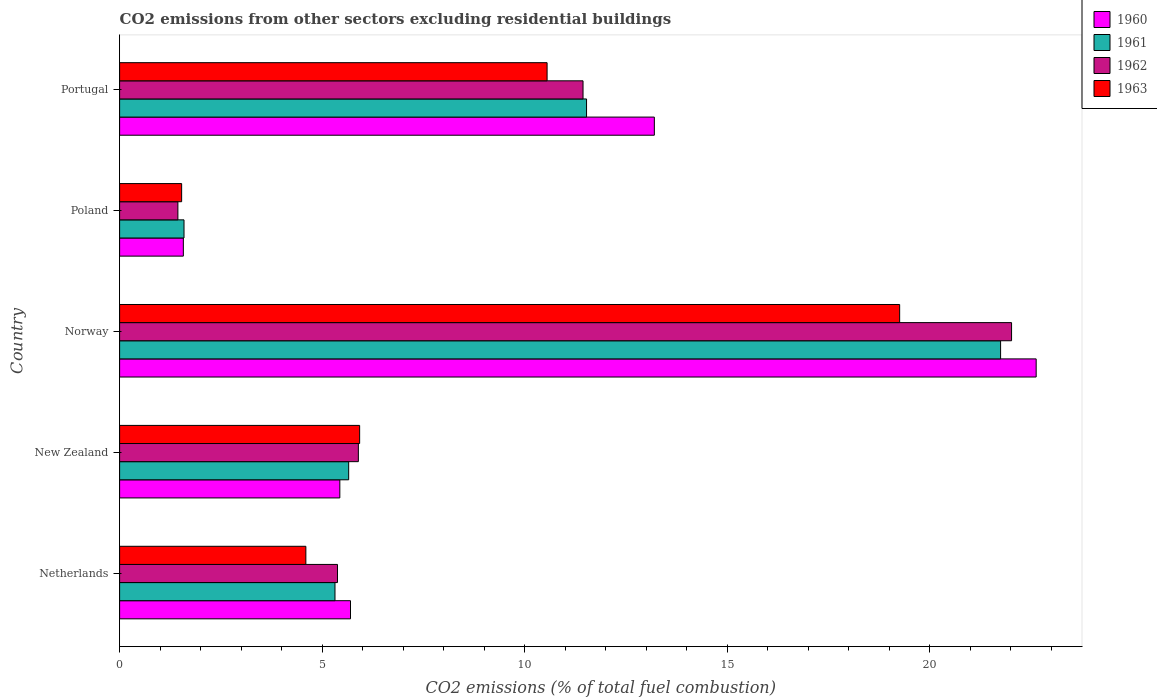How many different coloured bars are there?
Make the answer very short. 4. What is the label of the 4th group of bars from the top?
Your answer should be very brief. New Zealand. What is the total CO2 emitted in 1963 in Norway?
Ensure brevity in your answer.  19.26. Across all countries, what is the maximum total CO2 emitted in 1960?
Your answer should be very brief. 22.63. Across all countries, what is the minimum total CO2 emitted in 1961?
Keep it short and to the point. 1.59. In which country was the total CO2 emitted in 1963 minimum?
Keep it short and to the point. Poland. What is the total total CO2 emitted in 1963 in the graph?
Ensure brevity in your answer.  41.87. What is the difference between the total CO2 emitted in 1962 in Netherlands and that in Portugal?
Offer a very short reply. -6.06. What is the difference between the total CO2 emitted in 1962 in Poland and the total CO2 emitted in 1961 in Portugal?
Give a very brief answer. -10.09. What is the average total CO2 emitted in 1963 per country?
Your answer should be very brief. 8.37. What is the difference between the total CO2 emitted in 1962 and total CO2 emitted in 1963 in New Zealand?
Make the answer very short. -0.03. What is the ratio of the total CO2 emitted in 1963 in Netherlands to that in Poland?
Provide a short and direct response. 3. Is the total CO2 emitted in 1961 in Norway less than that in Poland?
Offer a terse response. No. What is the difference between the highest and the second highest total CO2 emitted in 1961?
Provide a succinct answer. 10.22. What is the difference between the highest and the lowest total CO2 emitted in 1960?
Provide a succinct answer. 21.05. In how many countries, is the total CO2 emitted in 1962 greater than the average total CO2 emitted in 1962 taken over all countries?
Offer a terse response. 2. Is the sum of the total CO2 emitted in 1963 in New Zealand and Poland greater than the maximum total CO2 emitted in 1962 across all countries?
Keep it short and to the point. No. Are all the bars in the graph horizontal?
Your response must be concise. Yes. What is the title of the graph?
Give a very brief answer. CO2 emissions from other sectors excluding residential buildings. Does "1992" appear as one of the legend labels in the graph?
Ensure brevity in your answer.  No. What is the label or title of the X-axis?
Keep it short and to the point. CO2 emissions (% of total fuel combustion). What is the CO2 emissions (% of total fuel combustion) of 1960 in Netherlands?
Your answer should be very brief. 5.7. What is the CO2 emissions (% of total fuel combustion) of 1961 in Netherlands?
Make the answer very short. 5.32. What is the CO2 emissions (% of total fuel combustion) in 1962 in Netherlands?
Ensure brevity in your answer.  5.38. What is the CO2 emissions (% of total fuel combustion) in 1963 in Netherlands?
Ensure brevity in your answer.  4.6. What is the CO2 emissions (% of total fuel combustion) in 1960 in New Zealand?
Provide a short and direct response. 5.44. What is the CO2 emissions (% of total fuel combustion) in 1961 in New Zealand?
Your answer should be compact. 5.66. What is the CO2 emissions (% of total fuel combustion) of 1962 in New Zealand?
Provide a short and direct response. 5.89. What is the CO2 emissions (% of total fuel combustion) in 1963 in New Zealand?
Provide a succinct answer. 5.93. What is the CO2 emissions (% of total fuel combustion) in 1960 in Norway?
Offer a very short reply. 22.63. What is the CO2 emissions (% of total fuel combustion) in 1961 in Norway?
Your response must be concise. 21.75. What is the CO2 emissions (% of total fuel combustion) in 1962 in Norway?
Offer a terse response. 22.02. What is the CO2 emissions (% of total fuel combustion) of 1963 in Norway?
Offer a very short reply. 19.26. What is the CO2 emissions (% of total fuel combustion) of 1960 in Poland?
Provide a short and direct response. 1.57. What is the CO2 emissions (% of total fuel combustion) of 1961 in Poland?
Keep it short and to the point. 1.59. What is the CO2 emissions (% of total fuel combustion) of 1962 in Poland?
Provide a short and direct response. 1.44. What is the CO2 emissions (% of total fuel combustion) in 1963 in Poland?
Give a very brief answer. 1.53. What is the CO2 emissions (% of total fuel combustion) in 1960 in Portugal?
Provide a succinct answer. 13.2. What is the CO2 emissions (% of total fuel combustion) in 1961 in Portugal?
Give a very brief answer. 11.53. What is the CO2 emissions (% of total fuel combustion) in 1962 in Portugal?
Make the answer very short. 11.44. What is the CO2 emissions (% of total fuel combustion) of 1963 in Portugal?
Provide a short and direct response. 10.55. Across all countries, what is the maximum CO2 emissions (% of total fuel combustion) in 1960?
Your response must be concise. 22.63. Across all countries, what is the maximum CO2 emissions (% of total fuel combustion) of 1961?
Your answer should be compact. 21.75. Across all countries, what is the maximum CO2 emissions (% of total fuel combustion) in 1962?
Ensure brevity in your answer.  22.02. Across all countries, what is the maximum CO2 emissions (% of total fuel combustion) in 1963?
Provide a short and direct response. 19.26. Across all countries, what is the minimum CO2 emissions (% of total fuel combustion) of 1960?
Your answer should be very brief. 1.57. Across all countries, what is the minimum CO2 emissions (% of total fuel combustion) of 1961?
Ensure brevity in your answer.  1.59. Across all countries, what is the minimum CO2 emissions (% of total fuel combustion) of 1962?
Ensure brevity in your answer.  1.44. Across all countries, what is the minimum CO2 emissions (% of total fuel combustion) in 1963?
Your response must be concise. 1.53. What is the total CO2 emissions (% of total fuel combustion) of 1960 in the graph?
Ensure brevity in your answer.  48.54. What is the total CO2 emissions (% of total fuel combustion) of 1961 in the graph?
Your answer should be very brief. 45.84. What is the total CO2 emissions (% of total fuel combustion) in 1962 in the graph?
Make the answer very short. 46.17. What is the total CO2 emissions (% of total fuel combustion) in 1963 in the graph?
Make the answer very short. 41.87. What is the difference between the CO2 emissions (% of total fuel combustion) of 1960 in Netherlands and that in New Zealand?
Your answer should be very brief. 0.26. What is the difference between the CO2 emissions (% of total fuel combustion) of 1961 in Netherlands and that in New Zealand?
Offer a very short reply. -0.34. What is the difference between the CO2 emissions (% of total fuel combustion) in 1962 in Netherlands and that in New Zealand?
Keep it short and to the point. -0.52. What is the difference between the CO2 emissions (% of total fuel combustion) of 1963 in Netherlands and that in New Zealand?
Provide a short and direct response. -1.33. What is the difference between the CO2 emissions (% of total fuel combustion) in 1960 in Netherlands and that in Norway?
Give a very brief answer. -16.93. What is the difference between the CO2 emissions (% of total fuel combustion) of 1961 in Netherlands and that in Norway?
Ensure brevity in your answer.  -16.43. What is the difference between the CO2 emissions (% of total fuel combustion) of 1962 in Netherlands and that in Norway?
Ensure brevity in your answer.  -16.64. What is the difference between the CO2 emissions (% of total fuel combustion) of 1963 in Netherlands and that in Norway?
Keep it short and to the point. -14.66. What is the difference between the CO2 emissions (% of total fuel combustion) in 1960 in Netherlands and that in Poland?
Offer a very short reply. 4.13. What is the difference between the CO2 emissions (% of total fuel combustion) of 1961 in Netherlands and that in Poland?
Your answer should be very brief. 3.73. What is the difference between the CO2 emissions (% of total fuel combustion) in 1962 in Netherlands and that in Poland?
Your response must be concise. 3.94. What is the difference between the CO2 emissions (% of total fuel combustion) of 1963 in Netherlands and that in Poland?
Keep it short and to the point. 3.07. What is the difference between the CO2 emissions (% of total fuel combustion) of 1960 in Netherlands and that in Portugal?
Your answer should be very brief. -7.5. What is the difference between the CO2 emissions (% of total fuel combustion) in 1961 in Netherlands and that in Portugal?
Ensure brevity in your answer.  -6.21. What is the difference between the CO2 emissions (% of total fuel combustion) in 1962 in Netherlands and that in Portugal?
Your answer should be very brief. -6.06. What is the difference between the CO2 emissions (% of total fuel combustion) of 1963 in Netherlands and that in Portugal?
Provide a short and direct response. -5.96. What is the difference between the CO2 emissions (% of total fuel combustion) in 1960 in New Zealand and that in Norway?
Provide a short and direct response. -17.19. What is the difference between the CO2 emissions (% of total fuel combustion) of 1961 in New Zealand and that in Norway?
Provide a succinct answer. -16.09. What is the difference between the CO2 emissions (% of total fuel combustion) in 1962 in New Zealand and that in Norway?
Make the answer very short. -16.13. What is the difference between the CO2 emissions (% of total fuel combustion) of 1963 in New Zealand and that in Norway?
Provide a succinct answer. -13.33. What is the difference between the CO2 emissions (% of total fuel combustion) in 1960 in New Zealand and that in Poland?
Give a very brief answer. 3.86. What is the difference between the CO2 emissions (% of total fuel combustion) in 1961 in New Zealand and that in Poland?
Your answer should be very brief. 4.07. What is the difference between the CO2 emissions (% of total fuel combustion) of 1962 in New Zealand and that in Poland?
Your answer should be very brief. 4.45. What is the difference between the CO2 emissions (% of total fuel combustion) of 1963 in New Zealand and that in Poland?
Ensure brevity in your answer.  4.39. What is the difference between the CO2 emissions (% of total fuel combustion) of 1960 in New Zealand and that in Portugal?
Provide a short and direct response. -7.76. What is the difference between the CO2 emissions (% of total fuel combustion) in 1961 in New Zealand and that in Portugal?
Provide a succinct answer. -5.87. What is the difference between the CO2 emissions (% of total fuel combustion) of 1962 in New Zealand and that in Portugal?
Make the answer very short. -5.55. What is the difference between the CO2 emissions (% of total fuel combustion) of 1963 in New Zealand and that in Portugal?
Give a very brief answer. -4.63. What is the difference between the CO2 emissions (% of total fuel combustion) in 1960 in Norway and that in Poland?
Your answer should be very brief. 21.05. What is the difference between the CO2 emissions (% of total fuel combustion) of 1961 in Norway and that in Poland?
Give a very brief answer. 20.16. What is the difference between the CO2 emissions (% of total fuel combustion) of 1962 in Norway and that in Poland?
Keep it short and to the point. 20.58. What is the difference between the CO2 emissions (% of total fuel combustion) of 1963 in Norway and that in Poland?
Your response must be concise. 17.73. What is the difference between the CO2 emissions (% of total fuel combustion) in 1960 in Norway and that in Portugal?
Offer a very short reply. 9.43. What is the difference between the CO2 emissions (% of total fuel combustion) in 1961 in Norway and that in Portugal?
Ensure brevity in your answer.  10.22. What is the difference between the CO2 emissions (% of total fuel combustion) in 1962 in Norway and that in Portugal?
Ensure brevity in your answer.  10.58. What is the difference between the CO2 emissions (% of total fuel combustion) in 1963 in Norway and that in Portugal?
Ensure brevity in your answer.  8.7. What is the difference between the CO2 emissions (% of total fuel combustion) of 1960 in Poland and that in Portugal?
Keep it short and to the point. -11.63. What is the difference between the CO2 emissions (% of total fuel combustion) in 1961 in Poland and that in Portugal?
Ensure brevity in your answer.  -9.94. What is the difference between the CO2 emissions (% of total fuel combustion) in 1962 in Poland and that in Portugal?
Ensure brevity in your answer.  -10. What is the difference between the CO2 emissions (% of total fuel combustion) in 1963 in Poland and that in Portugal?
Keep it short and to the point. -9.02. What is the difference between the CO2 emissions (% of total fuel combustion) in 1960 in Netherlands and the CO2 emissions (% of total fuel combustion) in 1961 in New Zealand?
Ensure brevity in your answer.  0.05. What is the difference between the CO2 emissions (% of total fuel combustion) in 1960 in Netherlands and the CO2 emissions (% of total fuel combustion) in 1962 in New Zealand?
Ensure brevity in your answer.  -0.19. What is the difference between the CO2 emissions (% of total fuel combustion) in 1960 in Netherlands and the CO2 emissions (% of total fuel combustion) in 1963 in New Zealand?
Offer a very short reply. -0.23. What is the difference between the CO2 emissions (% of total fuel combustion) in 1961 in Netherlands and the CO2 emissions (% of total fuel combustion) in 1962 in New Zealand?
Give a very brief answer. -0.58. What is the difference between the CO2 emissions (% of total fuel combustion) in 1961 in Netherlands and the CO2 emissions (% of total fuel combustion) in 1963 in New Zealand?
Provide a short and direct response. -0.61. What is the difference between the CO2 emissions (% of total fuel combustion) of 1962 in Netherlands and the CO2 emissions (% of total fuel combustion) of 1963 in New Zealand?
Make the answer very short. -0.55. What is the difference between the CO2 emissions (% of total fuel combustion) of 1960 in Netherlands and the CO2 emissions (% of total fuel combustion) of 1961 in Norway?
Your response must be concise. -16.05. What is the difference between the CO2 emissions (% of total fuel combustion) in 1960 in Netherlands and the CO2 emissions (% of total fuel combustion) in 1962 in Norway?
Provide a succinct answer. -16.32. What is the difference between the CO2 emissions (% of total fuel combustion) of 1960 in Netherlands and the CO2 emissions (% of total fuel combustion) of 1963 in Norway?
Your answer should be very brief. -13.56. What is the difference between the CO2 emissions (% of total fuel combustion) of 1961 in Netherlands and the CO2 emissions (% of total fuel combustion) of 1962 in Norway?
Provide a short and direct response. -16.7. What is the difference between the CO2 emissions (% of total fuel combustion) of 1961 in Netherlands and the CO2 emissions (% of total fuel combustion) of 1963 in Norway?
Your response must be concise. -13.94. What is the difference between the CO2 emissions (% of total fuel combustion) of 1962 in Netherlands and the CO2 emissions (% of total fuel combustion) of 1963 in Norway?
Make the answer very short. -13.88. What is the difference between the CO2 emissions (% of total fuel combustion) of 1960 in Netherlands and the CO2 emissions (% of total fuel combustion) of 1961 in Poland?
Provide a short and direct response. 4.11. What is the difference between the CO2 emissions (% of total fuel combustion) of 1960 in Netherlands and the CO2 emissions (% of total fuel combustion) of 1962 in Poland?
Your response must be concise. 4.26. What is the difference between the CO2 emissions (% of total fuel combustion) of 1960 in Netherlands and the CO2 emissions (% of total fuel combustion) of 1963 in Poland?
Your answer should be very brief. 4.17. What is the difference between the CO2 emissions (% of total fuel combustion) of 1961 in Netherlands and the CO2 emissions (% of total fuel combustion) of 1962 in Poland?
Give a very brief answer. 3.88. What is the difference between the CO2 emissions (% of total fuel combustion) of 1961 in Netherlands and the CO2 emissions (% of total fuel combustion) of 1963 in Poland?
Your response must be concise. 3.79. What is the difference between the CO2 emissions (% of total fuel combustion) in 1962 in Netherlands and the CO2 emissions (% of total fuel combustion) in 1963 in Poland?
Offer a terse response. 3.85. What is the difference between the CO2 emissions (% of total fuel combustion) in 1960 in Netherlands and the CO2 emissions (% of total fuel combustion) in 1961 in Portugal?
Offer a very short reply. -5.83. What is the difference between the CO2 emissions (% of total fuel combustion) in 1960 in Netherlands and the CO2 emissions (% of total fuel combustion) in 1962 in Portugal?
Your answer should be compact. -5.74. What is the difference between the CO2 emissions (% of total fuel combustion) in 1960 in Netherlands and the CO2 emissions (% of total fuel combustion) in 1963 in Portugal?
Your answer should be compact. -4.85. What is the difference between the CO2 emissions (% of total fuel combustion) of 1961 in Netherlands and the CO2 emissions (% of total fuel combustion) of 1962 in Portugal?
Offer a very short reply. -6.12. What is the difference between the CO2 emissions (% of total fuel combustion) in 1961 in Netherlands and the CO2 emissions (% of total fuel combustion) in 1963 in Portugal?
Provide a succinct answer. -5.24. What is the difference between the CO2 emissions (% of total fuel combustion) of 1962 in Netherlands and the CO2 emissions (% of total fuel combustion) of 1963 in Portugal?
Ensure brevity in your answer.  -5.17. What is the difference between the CO2 emissions (% of total fuel combustion) of 1960 in New Zealand and the CO2 emissions (% of total fuel combustion) of 1961 in Norway?
Your answer should be very brief. -16.31. What is the difference between the CO2 emissions (% of total fuel combustion) of 1960 in New Zealand and the CO2 emissions (% of total fuel combustion) of 1962 in Norway?
Ensure brevity in your answer.  -16.58. What is the difference between the CO2 emissions (% of total fuel combustion) of 1960 in New Zealand and the CO2 emissions (% of total fuel combustion) of 1963 in Norway?
Your answer should be compact. -13.82. What is the difference between the CO2 emissions (% of total fuel combustion) of 1961 in New Zealand and the CO2 emissions (% of total fuel combustion) of 1962 in Norway?
Make the answer very short. -16.36. What is the difference between the CO2 emissions (% of total fuel combustion) of 1961 in New Zealand and the CO2 emissions (% of total fuel combustion) of 1963 in Norway?
Give a very brief answer. -13.6. What is the difference between the CO2 emissions (% of total fuel combustion) of 1962 in New Zealand and the CO2 emissions (% of total fuel combustion) of 1963 in Norway?
Make the answer very short. -13.36. What is the difference between the CO2 emissions (% of total fuel combustion) of 1960 in New Zealand and the CO2 emissions (% of total fuel combustion) of 1961 in Poland?
Your answer should be compact. 3.85. What is the difference between the CO2 emissions (% of total fuel combustion) of 1960 in New Zealand and the CO2 emissions (% of total fuel combustion) of 1962 in Poland?
Offer a terse response. 4. What is the difference between the CO2 emissions (% of total fuel combustion) in 1960 in New Zealand and the CO2 emissions (% of total fuel combustion) in 1963 in Poland?
Give a very brief answer. 3.91. What is the difference between the CO2 emissions (% of total fuel combustion) of 1961 in New Zealand and the CO2 emissions (% of total fuel combustion) of 1962 in Poland?
Offer a terse response. 4.22. What is the difference between the CO2 emissions (% of total fuel combustion) of 1961 in New Zealand and the CO2 emissions (% of total fuel combustion) of 1963 in Poland?
Make the answer very short. 4.12. What is the difference between the CO2 emissions (% of total fuel combustion) of 1962 in New Zealand and the CO2 emissions (% of total fuel combustion) of 1963 in Poland?
Your response must be concise. 4.36. What is the difference between the CO2 emissions (% of total fuel combustion) in 1960 in New Zealand and the CO2 emissions (% of total fuel combustion) in 1961 in Portugal?
Your answer should be compact. -6.09. What is the difference between the CO2 emissions (% of total fuel combustion) in 1960 in New Zealand and the CO2 emissions (% of total fuel combustion) in 1962 in Portugal?
Provide a succinct answer. -6. What is the difference between the CO2 emissions (% of total fuel combustion) in 1960 in New Zealand and the CO2 emissions (% of total fuel combustion) in 1963 in Portugal?
Offer a terse response. -5.12. What is the difference between the CO2 emissions (% of total fuel combustion) of 1961 in New Zealand and the CO2 emissions (% of total fuel combustion) of 1962 in Portugal?
Offer a very short reply. -5.79. What is the difference between the CO2 emissions (% of total fuel combustion) of 1961 in New Zealand and the CO2 emissions (% of total fuel combustion) of 1963 in Portugal?
Ensure brevity in your answer.  -4.9. What is the difference between the CO2 emissions (% of total fuel combustion) in 1962 in New Zealand and the CO2 emissions (% of total fuel combustion) in 1963 in Portugal?
Keep it short and to the point. -4.66. What is the difference between the CO2 emissions (% of total fuel combustion) in 1960 in Norway and the CO2 emissions (% of total fuel combustion) in 1961 in Poland?
Provide a short and direct response. 21.04. What is the difference between the CO2 emissions (% of total fuel combustion) of 1960 in Norway and the CO2 emissions (% of total fuel combustion) of 1962 in Poland?
Give a very brief answer. 21.19. What is the difference between the CO2 emissions (% of total fuel combustion) in 1960 in Norway and the CO2 emissions (% of total fuel combustion) in 1963 in Poland?
Ensure brevity in your answer.  21.1. What is the difference between the CO2 emissions (% of total fuel combustion) in 1961 in Norway and the CO2 emissions (% of total fuel combustion) in 1962 in Poland?
Provide a short and direct response. 20.31. What is the difference between the CO2 emissions (% of total fuel combustion) of 1961 in Norway and the CO2 emissions (% of total fuel combustion) of 1963 in Poland?
Your answer should be very brief. 20.22. What is the difference between the CO2 emissions (% of total fuel combustion) in 1962 in Norway and the CO2 emissions (% of total fuel combustion) in 1963 in Poland?
Make the answer very short. 20.49. What is the difference between the CO2 emissions (% of total fuel combustion) in 1960 in Norway and the CO2 emissions (% of total fuel combustion) in 1961 in Portugal?
Provide a succinct answer. 11.1. What is the difference between the CO2 emissions (% of total fuel combustion) of 1960 in Norway and the CO2 emissions (% of total fuel combustion) of 1962 in Portugal?
Provide a succinct answer. 11.19. What is the difference between the CO2 emissions (% of total fuel combustion) in 1960 in Norway and the CO2 emissions (% of total fuel combustion) in 1963 in Portugal?
Keep it short and to the point. 12.07. What is the difference between the CO2 emissions (% of total fuel combustion) of 1961 in Norway and the CO2 emissions (% of total fuel combustion) of 1962 in Portugal?
Give a very brief answer. 10.31. What is the difference between the CO2 emissions (% of total fuel combustion) of 1961 in Norway and the CO2 emissions (% of total fuel combustion) of 1963 in Portugal?
Offer a very short reply. 11.2. What is the difference between the CO2 emissions (% of total fuel combustion) in 1962 in Norway and the CO2 emissions (% of total fuel combustion) in 1963 in Portugal?
Make the answer very short. 11.47. What is the difference between the CO2 emissions (% of total fuel combustion) in 1960 in Poland and the CO2 emissions (% of total fuel combustion) in 1961 in Portugal?
Provide a short and direct response. -9.95. What is the difference between the CO2 emissions (% of total fuel combustion) of 1960 in Poland and the CO2 emissions (% of total fuel combustion) of 1962 in Portugal?
Keep it short and to the point. -9.87. What is the difference between the CO2 emissions (% of total fuel combustion) in 1960 in Poland and the CO2 emissions (% of total fuel combustion) in 1963 in Portugal?
Provide a short and direct response. -8.98. What is the difference between the CO2 emissions (% of total fuel combustion) of 1961 in Poland and the CO2 emissions (% of total fuel combustion) of 1962 in Portugal?
Offer a terse response. -9.85. What is the difference between the CO2 emissions (% of total fuel combustion) of 1961 in Poland and the CO2 emissions (% of total fuel combustion) of 1963 in Portugal?
Your answer should be very brief. -8.96. What is the difference between the CO2 emissions (% of total fuel combustion) in 1962 in Poland and the CO2 emissions (% of total fuel combustion) in 1963 in Portugal?
Your answer should be compact. -9.11. What is the average CO2 emissions (% of total fuel combustion) in 1960 per country?
Provide a succinct answer. 9.71. What is the average CO2 emissions (% of total fuel combustion) of 1961 per country?
Provide a succinct answer. 9.17. What is the average CO2 emissions (% of total fuel combustion) of 1962 per country?
Provide a succinct answer. 9.23. What is the average CO2 emissions (% of total fuel combustion) of 1963 per country?
Offer a very short reply. 8.37. What is the difference between the CO2 emissions (% of total fuel combustion) of 1960 and CO2 emissions (% of total fuel combustion) of 1961 in Netherlands?
Keep it short and to the point. 0.38. What is the difference between the CO2 emissions (% of total fuel combustion) of 1960 and CO2 emissions (% of total fuel combustion) of 1962 in Netherlands?
Keep it short and to the point. 0.32. What is the difference between the CO2 emissions (% of total fuel combustion) in 1960 and CO2 emissions (% of total fuel combustion) in 1963 in Netherlands?
Your answer should be very brief. 1.1. What is the difference between the CO2 emissions (% of total fuel combustion) of 1961 and CO2 emissions (% of total fuel combustion) of 1962 in Netherlands?
Give a very brief answer. -0.06. What is the difference between the CO2 emissions (% of total fuel combustion) in 1961 and CO2 emissions (% of total fuel combustion) in 1963 in Netherlands?
Give a very brief answer. 0.72. What is the difference between the CO2 emissions (% of total fuel combustion) of 1962 and CO2 emissions (% of total fuel combustion) of 1963 in Netherlands?
Keep it short and to the point. 0.78. What is the difference between the CO2 emissions (% of total fuel combustion) of 1960 and CO2 emissions (% of total fuel combustion) of 1961 in New Zealand?
Your answer should be compact. -0.22. What is the difference between the CO2 emissions (% of total fuel combustion) in 1960 and CO2 emissions (% of total fuel combustion) in 1962 in New Zealand?
Your answer should be very brief. -0.46. What is the difference between the CO2 emissions (% of total fuel combustion) in 1960 and CO2 emissions (% of total fuel combustion) in 1963 in New Zealand?
Provide a short and direct response. -0.49. What is the difference between the CO2 emissions (% of total fuel combustion) of 1961 and CO2 emissions (% of total fuel combustion) of 1962 in New Zealand?
Offer a very short reply. -0.24. What is the difference between the CO2 emissions (% of total fuel combustion) of 1961 and CO2 emissions (% of total fuel combustion) of 1963 in New Zealand?
Your response must be concise. -0.27. What is the difference between the CO2 emissions (% of total fuel combustion) of 1962 and CO2 emissions (% of total fuel combustion) of 1963 in New Zealand?
Offer a terse response. -0.03. What is the difference between the CO2 emissions (% of total fuel combustion) in 1960 and CO2 emissions (% of total fuel combustion) in 1961 in Norway?
Offer a terse response. 0.88. What is the difference between the CO2 emissions (% of total fuel combustion) of 1960 and CO2 emissions (% of total fuel combustion) of 1962 in Norway?
Offer a very short reply. 0.61. What is the difference between the CO2 emissions (% of total fuel combustion) of 1960 and CO2 emissions (% of total fuel combustion) of 1963 in Norway?
Ensure brevity in your answer.  3.37. What is the difference between the CO2 emissions (% of total fuel combustion) of 1961 and CO2 emissions (% of total fuel combustion) of 1962 in Norway?
Make the answer very short. -0.27. What is the difference between the CO2 emissions (% of total fuel combustion) in 1961 and CO2 emissions (% of total fuel combustion) in 1963 in Norway?
Ensure brevity in your answer.  2.49. What is the difference between the CO2 emissions (% of total fuel combustion) in 1962 and CO2 emissions (% of total fuel combustion) in 1963 in Norway?
Give a very brief answer. 2.76. What is the difference between the CO2 emissions (% of total fuel combustion) of 1960 and CO2 emissions (% of total fuel combustion) of 1961 in Poland?
Give a very brief answer. -0.02. What is the difference between the CO2 emissions (% of total fuel combustion) of 1960 and CO2 emissions (% of total fuel combustion) of 1962 in Poland?
Ensure brevity in your answer.  0.13. What is the difference between the CO2 emissions (% of total fuel combustion) in 1960 and CO2 emissions (% of total fuel combustion) in 1963 in Poland?
Your answer should be compact. 0.04. What is the difference between the CO2 emissions (% of total fuel combustion) of 1961 and CO2 emissions (% of total fuel combustion) of 1962 in Poland?
Provide a succinct answer. 0.15. What is the difference between the CO2 emissions (% of total fuel combustion) of 1961 and CO2 emissions (% of total fuel combustion) of 1963 in Poland?
Your response must be concise. 0.06. What is the difference between the CO2 emissions (% of total fuel combustion) in 1962 and CO2 emissions (% of total fuel combustion) in 1963 in Poland?
Offer a terse response. -0.09. What is the difference between the CO2 emissions (% of total fuel combustion) in 1960 and CO2 emissions (% of total fuel combustion) in 1961 in Portugal?
Your response must be concise. 1.67. What is the difference between the CO2 emissions (% of total fuel combustion) in 1960 and CO2 emissions (% of total fuel combustion) in 1962 in Portugal?
Provide a succinct answer. 1.76. What is the difference between the CO2 emissions (% of total fuel combustion) of 1960 and CO2 emissions (% of total fuel combustion) of 1963 in Portugal?
Ensure brevity in your answer.  2.65. What is the difference between the CO2 emissions (% of total fuel combustion) in 1961 and CO2 emissions (% of total fuel combustion) in 1962 in Portugal?
Give a very brief answer. 0.09. What is the difference between the CO2 emissions (% of total fuel combustion) of 1961 and CO2 emissions (% of total fuel combustion) of 1963 in Portugal?
Keep it short and to the point. 0.97. What is the difference between the CO2 emissions (% of total fuel combustion) in 1962 and CO2 emissions (% of total fuel combustion) in 1963 in Portugal?
Keep it short and to the point. 0.89. What is the ratio of the CO2 emissions (% of total fuel combustion) in 1960 in Netherlands to that in New Zealand?
Your response must be concise. 1.05. What is the ratio of the CO2 emissions (% of total fuel combustion) in 1961 in Netherlands to that in New Zealand?
Keep it short and to the point. 0.94. What is the ratio of the CO2 emissions (% of total fuel combustion) of 1962 in Netherlands to that in New Zealand?
Your answer should be very brief. 0.91. What is the ratio of the CO2 emissions (% of total fuel combustion) of 1963 in Netherlands to that in New Zealand?
Keep it short and to the point. 0.78. What is the ratio of the CO2 emissions (% of total fuel combustion) of 1960 in Netherlands to that in Norway?
Make the answer very short. 0.25. What is the ratio of the CO2 emissions (% of total fuel combustion) of 1961 in Netherlands to that in Norway?
Keep it short and to the point. 0.24. What is the ratio of the CO2 emissions (% of total fuel combustion) in 1962 in Netherlands to that in Norway?
Your response must be concise. 0.24. What is the ratio of the CO2 emissions (% of total fuel combustion) of 1963 in Netherlands to that in Norway?
Ensure brevity in your answer.  0.24. What is the ratio of the CO2 emissions (% of total fuel combustion) in 1960 in Netherlands to that in Poland?
Provide a succinct answer. 3.62. What is the ratio of the CO2 emissions (% of total fuel combustion) in 1961 in Netherlands to that in Poland?
Provide a succinct answer. 3.34. What is the ratio of the CO2 emissions (% of total fuel combustion) of 1962 in Netherlands to that in Poland?
Provide a short and direct response. 3.74. What is the ratio of the CO2 emissions (% of total fuel combustion) in 1963 in Netherlands to that in Poland?
Your answer should be very brief. 3. What is the ratio of the CO2 emissions (% of total fuel combustion) of 1960 in Netherlands to that in Portugal?
Your answer should be compact. 0.43. What is the ratio of the CO2 emissions (% of total fuel combustion) of 1961 in Netherlands to that in Portugal?
Provide a succinct answer. 0.46. What is the ratio of the CO2 emissions (% of total fuel combustion) in 1962 in Netherlands to that in Portugal?
Offer a very short reply. 0.47. What is the ratio of the CO2 emissions (% of total fuel combustion) in 1963 in Netherlands to that in Portugal?
Your answer should be very brief. 0.44. What is the ratio of the CO2 emissions (% of total fuel combustion) of 1960 in New Zealand to that in Norway?
Provide a succinct answer. 0.24. What is the ratio of the CO2 emissions (% of total fuel combustion) in 1961 in New Zealand to that in Norway?
Your answer should be very brief. 0.26. What is the ratio of the CO2 emissions (% of total fuel combustion) in 1962 in New Zealand to that in Norway?
Your answer should be very brief. 0.27. What is the ratio of the CO2 emissions (% of total fuel combustion) in 1963 in New Zealand to that in Norway?
Your answer should be very brief. 0.31. What is the ratio of the CO2 emissions (% of total fuel combustion) in 1960 in New Zealand to that in Poland?
Offer a very short reply. 3.46. What is the ratio of the CO2 emissions (% of total fuel combustion) in 1961 in New Zealand to that in Poland?
Provide a short and direct response. 3.56. What is the ratio of the CO2 emissions (% of total fuel combustion) in 1962 in New Zealand to that in Poland?
Ensure brevity in your answer.  4.1. What is the ratio of the CO2 emissions (% of total fuel combustion) of 1963 in New Zealand to that in Poland?
Your answer should be very brief. 3.87. What is the ratio of the CO2 emissions (% of total fuel combustion) of 1960 in New Zealand to that in Portugal?
Give a very brief answer. 0.41. What is the ratio of the CO2 emissions (% of total fuel combustion) in 1961 in New Zealand to that in Portugal?
Offer a very short reply. 0.49. What is the ratio of the CO2 emissions (% of total fuel combustion) in 1962 in New Zealand to that in Portugal?
Offer a very short reply. 0.52. What is the ratio of the CO2 emissions (% of total fuel combustion) of 1963 in New Zealand to that in Portugal?
Provide a short and direct response. 0.56. What is the ratio of the CO2 emissions (% of total fuel combustion) of 1960 in Norway to that in Poland?
Offer a terse response. 14.38. What is the ratio of the CO2 emissions (% of total fuel combustion) in 1961 in Norway to that in Poland?
Ensure brevity in your answer.  13.68. What is the ratio of the CO2 emissions (% of total fuel combustion) of 1962 in Norway to that in Poland?
Provide a succinct answer. 15.3. What is the ratio of the CO2 emissions (% of total fuel combustion) of 1963 in Norway to that in Poland?
Keep it short and to the point. 12.57. What is the ratio of the CO2 emissions (% of total fuel combustion) of 1960 in Norway to that in Portugal?
Make the answer very short. 1.71. What is the ratio of the CO2 emissions (% of total fuel combustion) in 1961 in Norway to that in Portugal?
Provide a short and direct response. 1.89. What is the ratio of the CO2 emissions (% of total fuel combustion) of 1962 in Norway to that in Portugal?
Your answer should be compact. 1.92. What is the ratio of the CO2 emissions (% of total fuel combustion) in 1963 in Norway to that in Portugal?
Keep it short and to the point. 1.82. What is the ratio of the CO2 emissions (% of total fuel combustion) in 1960 in Poland to that in Portugal?
Make the answer very short. 0.12. What is the ratio of the CO2 emissions (% of total fuel combustion) in 1961 in Poland to that in Portugal?
Your answer should be compact. 0.14. What is the ratio of the CO2 emissions (% of total fuel combustion) of 1962 in Poland to that in Portugal?
Your response must be concise. 0.13. What is the ratio of the CO2 emissions (% of total fuel combustion) in 1963 in Poland to that in Portugal?
Offer a very short reply. 0.15. What is the difference between the highest and the second highest CO2 emissions (% of total fuel combustion) of 1960?
Offer a terse response. 9.43. What is the difference between the highest and the second highest CO2 emissions (% of total fuel combustion) in 1961?
Give a very brief answer. 10.22. What is the difference between the highest and the second highest CO2 emissions (% of total fuel combustion) of 1962?
Make the answer very short. 10.58. What is the difference between the highest and the second highest CO2 emissions (% of total fuel combustion) of 1963?
Your answer should be compact. 8.7. What is the difference between the highest and the lowest CO2 emissions (% of total fuel combustion) in 1960?
Your answer should be very brief. 21.05. What is the difference between the highest and the lowest CO2 emissions (% of total fuel combustion) in 1961?
Give a very brief answer. 20.16. What is the difference between the highest and the lowest CO2 emissions (% of total fuel combustion) in 1962?
Provide a succinct answer. 20.58. What is the difference between the highest and the lowest CO2 emissions (% of total fuel combustion) in 1963?
Keep it short and to the point. 17.73. 